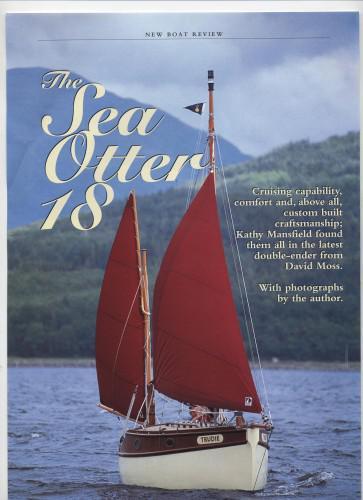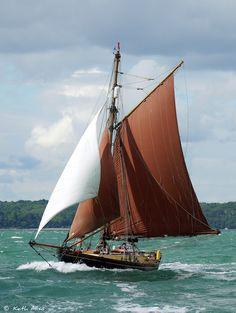The first image is the image on the left, the second image is the image on the right. Analyze the images presented: Is the assertion "All of the sails on the boat in the image to the right happen to be red." valid? Answer yes or no. No. The first image is the image on the left, the second image is the image on the right. Assess this claim about the two images: "in the right pic the nearest pic has three sails". Correct or not? Answer yes or no. Yes. 